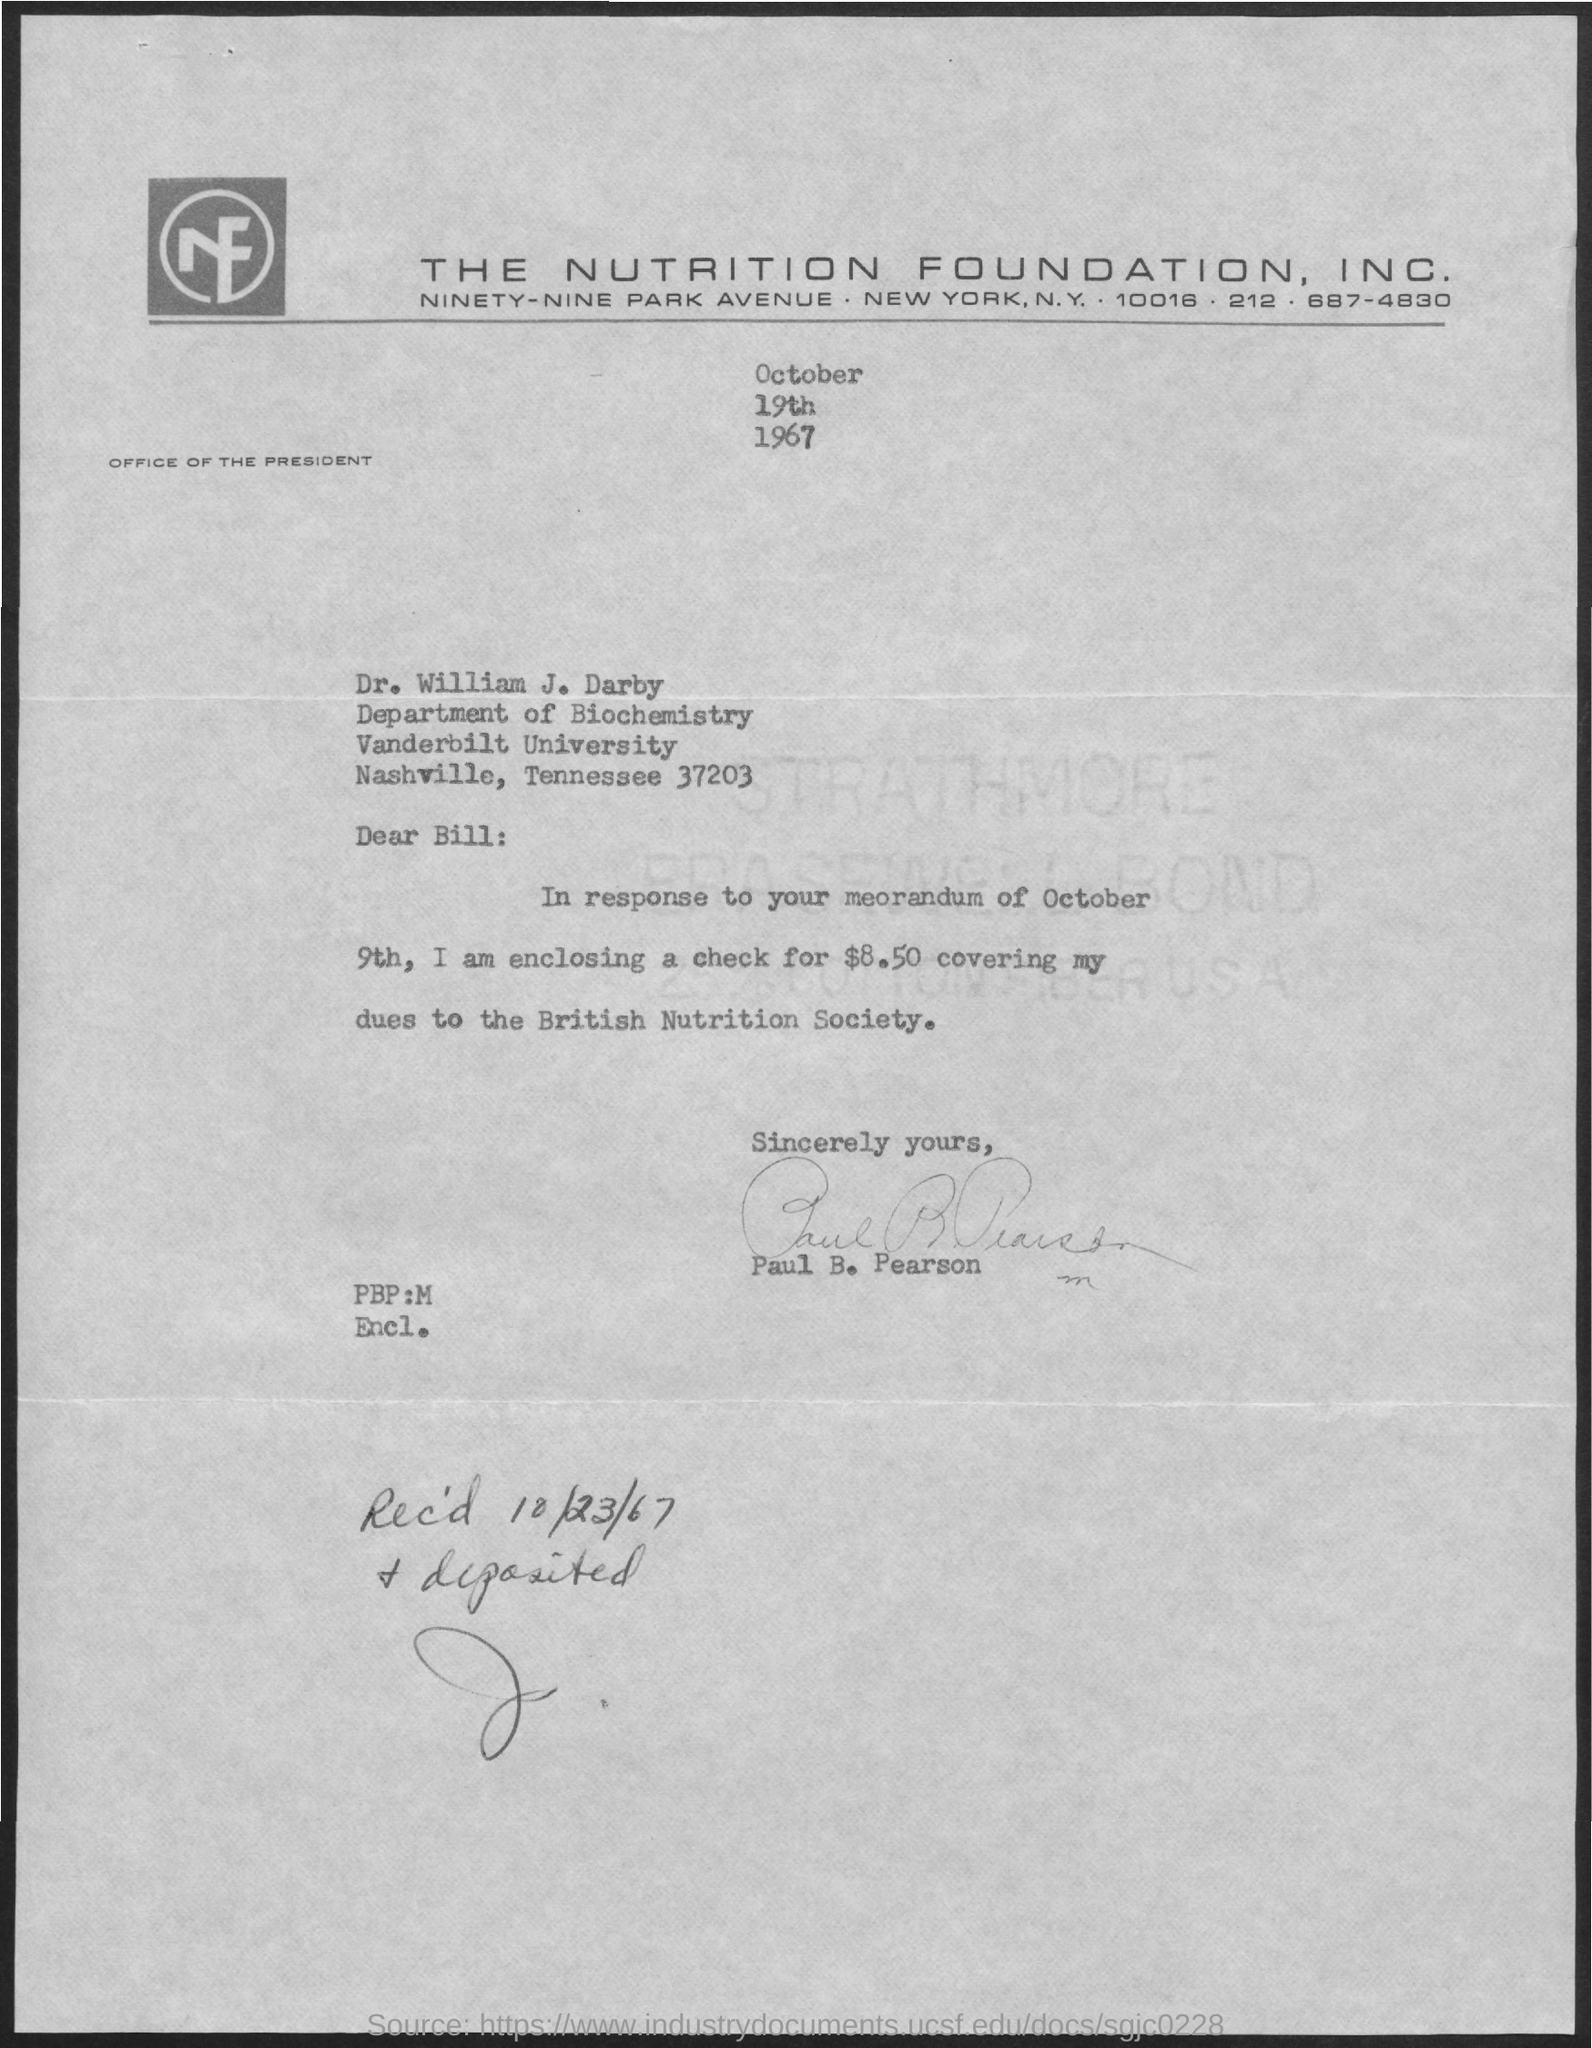Specify some key components in this picture. The letter is from Paul b. Pearson. The response contained in the letter is from the memorandum of October 9th. On October 23, 1967, the item was received and deposited. The document indicates that the date is October 19th, 1967. The letter is addressed to Dr. William J. Darby. 